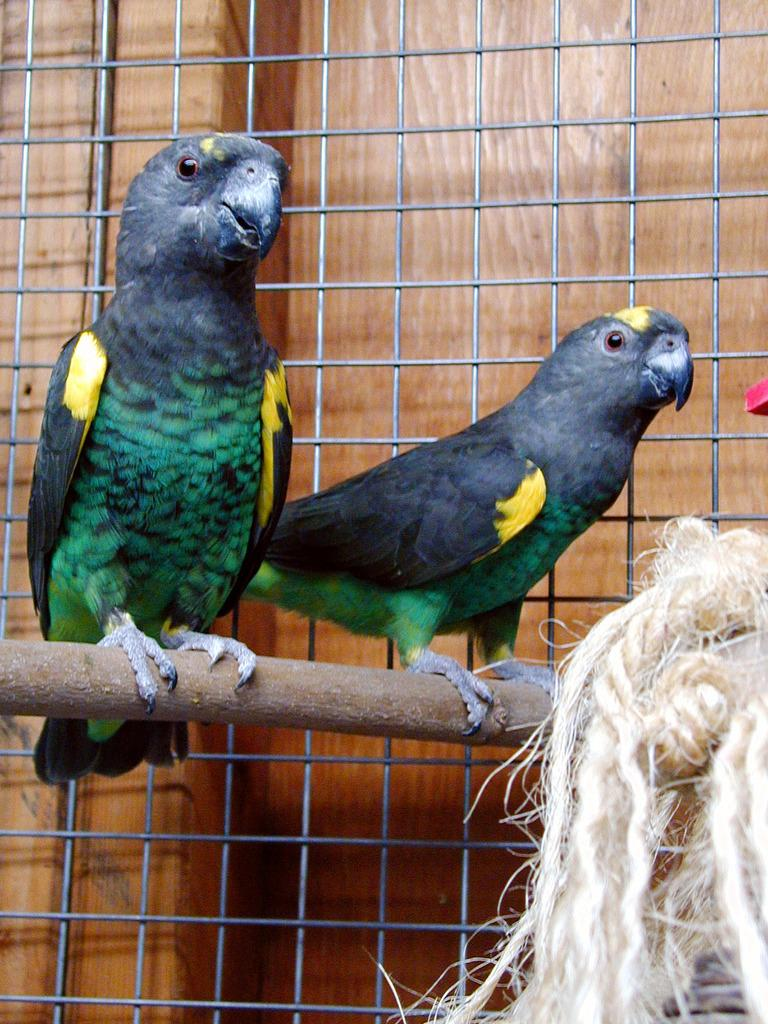How many parrots are in the image? There are two parrots in the image. What are the parrots standing on? The parrots are standing on a stick. What type of fencing is present in the image? There is steel fencing in the image. What can be seen in the bottom right of the image? Ropes are visible in the bottom right of the image. What type of jewel is the parrot holding in its beak? There is no jewel present in the image; the parrots are standing on a stick. 